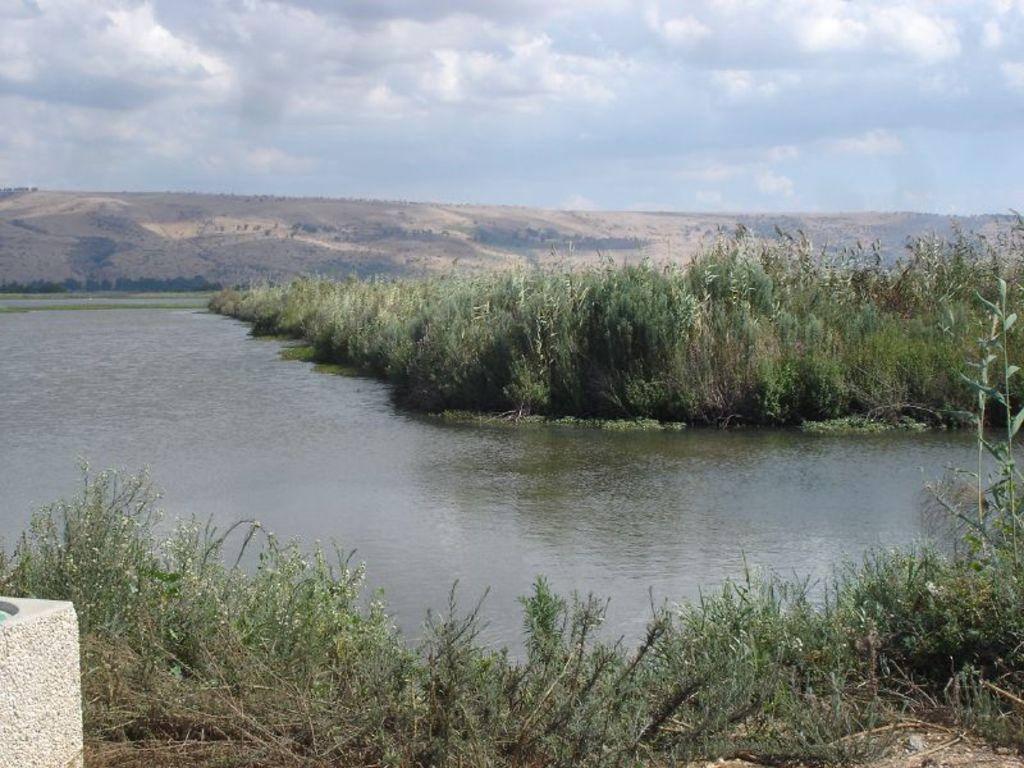In one or two sentences, can you explain what this image depicts? This picture might be taken from outside of the city. In this image, on the left side, we can see a stone. In the background, we can see some trees, plants, rocks. At the top, we can see a sky which is cloudy, at the bottom, we can see a water in a lake and some plants and grass on the land. 